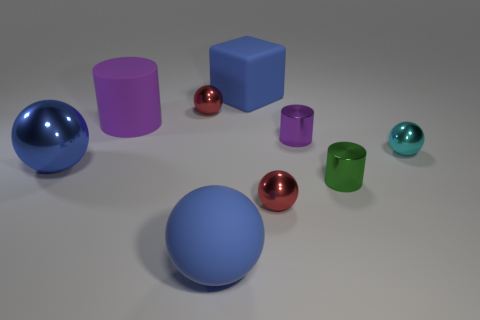Subtract all big shiny spheres. How many spheres are left? 4 Subtract all red balls. How many balls are left? 3 Subtract all gray spheres. Subtract all green cylinders. How many spheres are left? 5 Add 1 tiny blue matte spheres. How many objects exist? 10 Subtract 1 green cylinders. How many objects are left? 8 Subtract all spheres. How many objects are left? 4 Subtract all big purple metallic objects. Subtract all tiny red metallic balls. How many objects are left? 7 Add 1 big blue rubber balls. How many big blue rubber balls are left? 2 Add 1 small brown rubber cylinders. How many small brown rubber cylinders exist? 1 